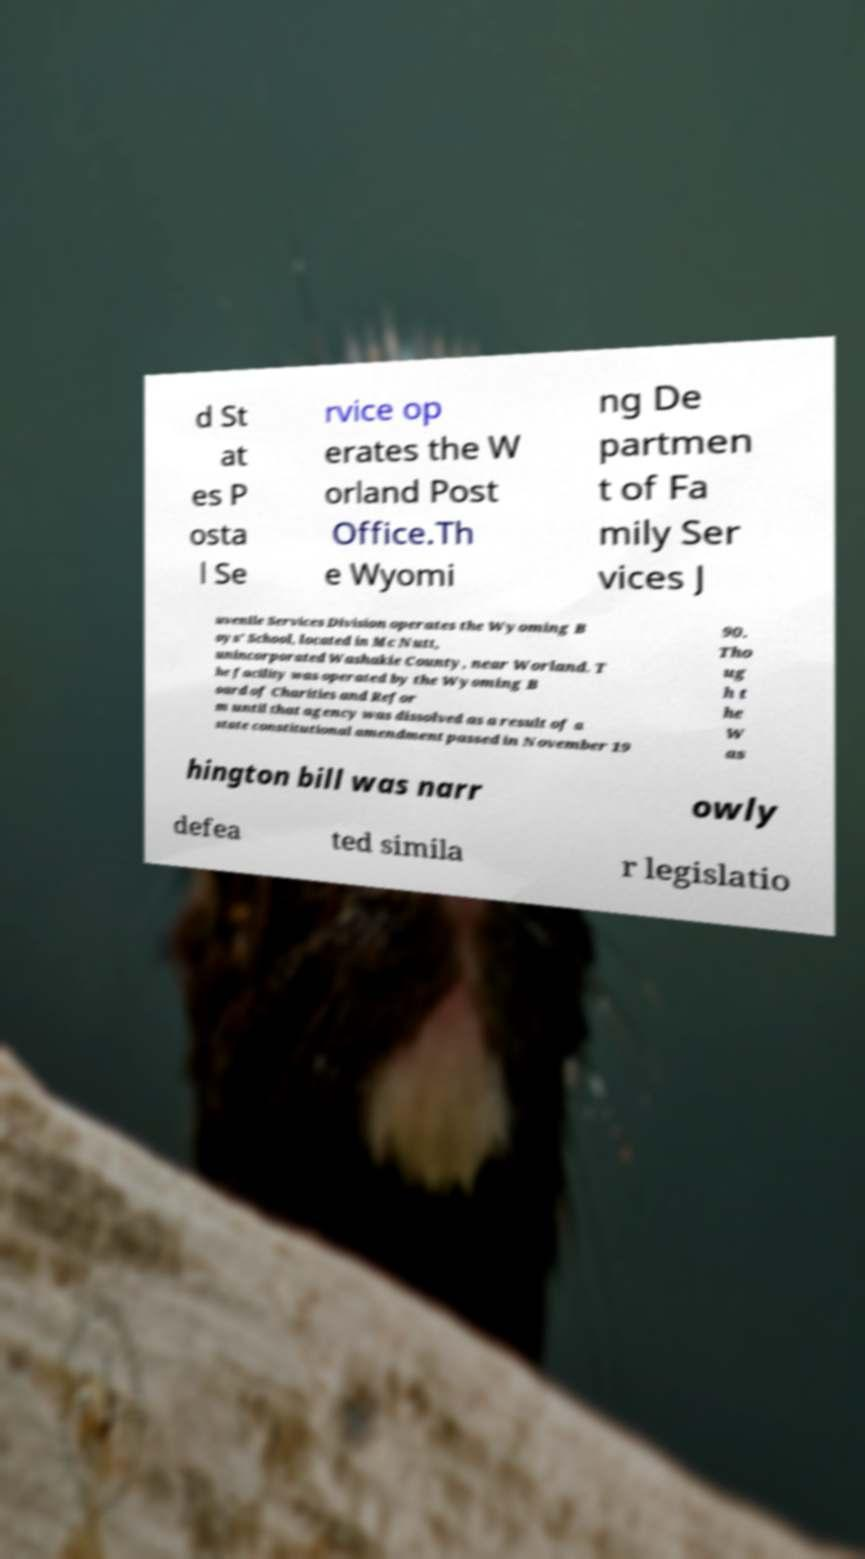I need the written content from this picture converted into text. Can you do that? d St at es P osta l Se rvice op erates the W orland Post Office.Th e Wyomi ng De partmen t of Fa mily Ser vices J uvenile Services Division operates the Wyoming B oys' School, located in Mc Nutt, unincorporated Washakie County, near Worland. T he facility was operated by the Wyoming B oard of Charities and Refor m until that agency was dissolved as a result of a state constitutional amendment passed in November 19 90. Tho ug h t he W as hington bill was narr owly defea ted simila r legislatio 